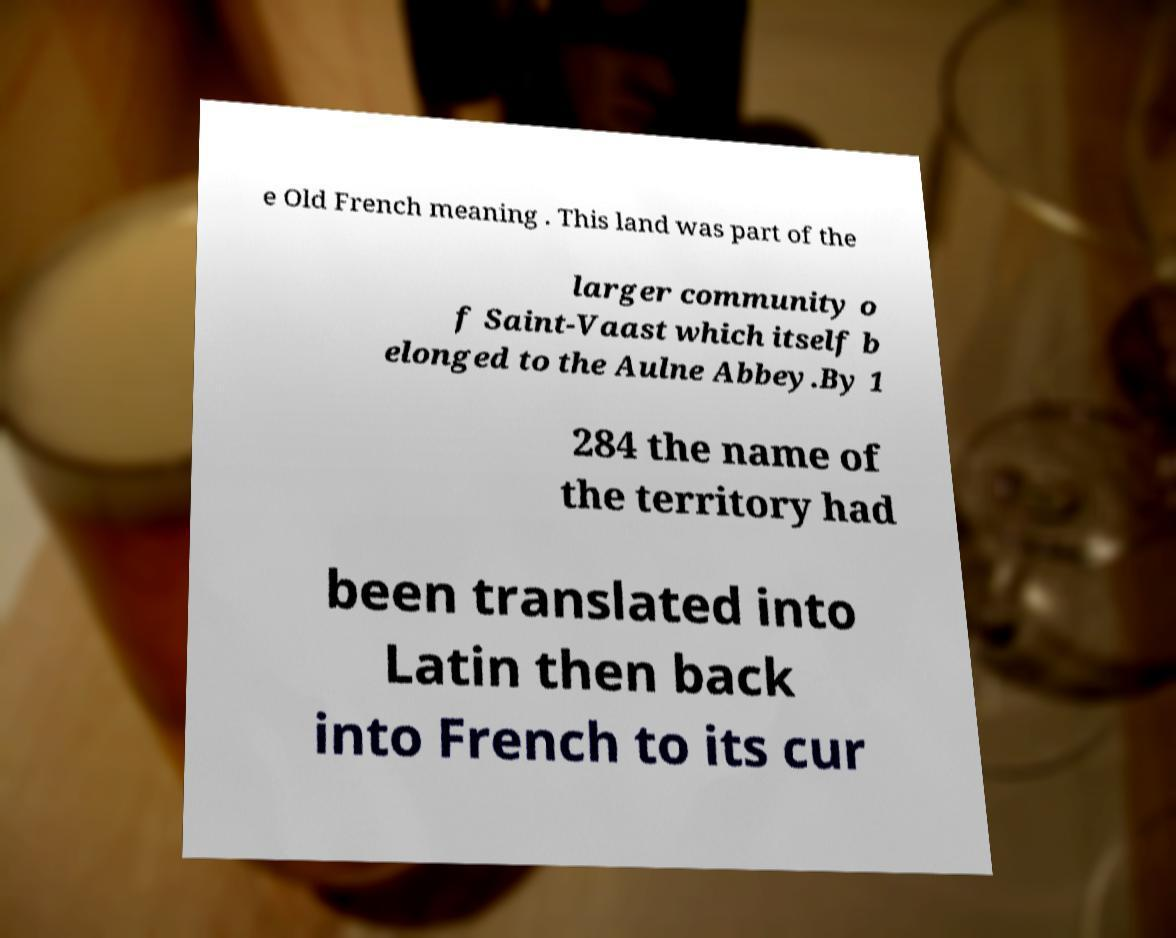There's text embedded in this image that I need extracted. Can you transcribe it verbatim? e Old French meaning . This land was part of the larger community o f Saint-Vaast which itself b elonged to the Aulne Abbey.By 1 284 the name of the territory had been translated into Latin then back into French to its cur 